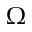Convert formula to latex. <formula><loc_0><loc_0><loc_500><loc_500>\Omega</formula> 